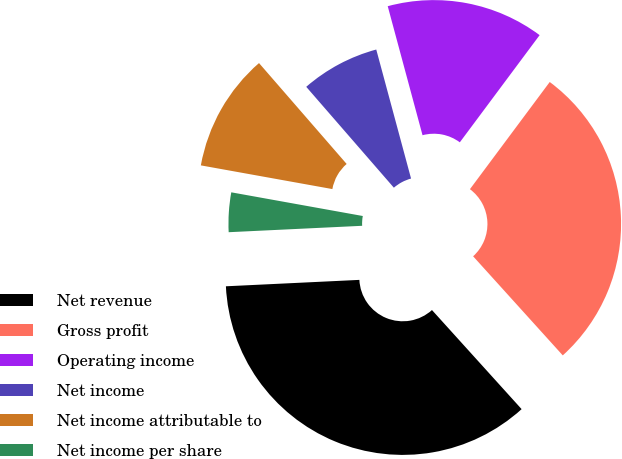<chart> <loc_0><loc_0><loc_500><loc_500><pie_chart><fcel>Net revenue<fcel>Gross profit<fcel>Operating income<fcel>Net income<fcel>Net income attributable to<fcel>Net income per share<nl><fcel>35.94%<fcel>28.11%<fcel>14.38%<fcel>7.19%<fcel>10.78%<fcel>3.6%<nl></chart> 